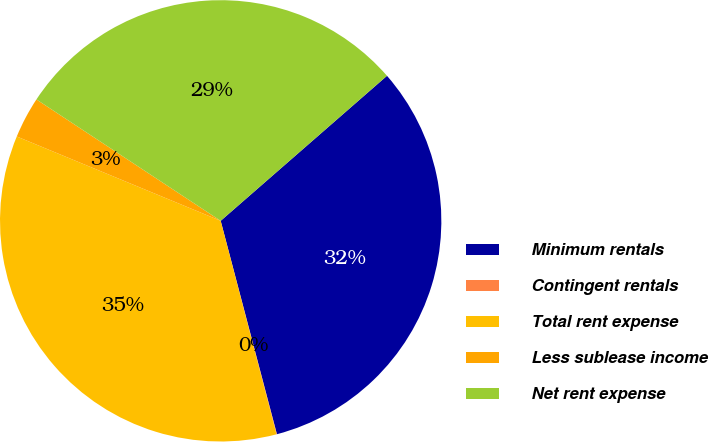Convert chart to OTSL. <chart><loc_0><loc_0><loc_500><loc_500><pie_chart><fcel>Minimum rentals<fcel>Contingent rentals<fcel>Total rent expense<fcel>Less sublease income<fcel>Net rent expense<nl><fcel>32.31%<fcel>0.03%<fcel>35.31%<fcel>3.03%<fcel>29.31%<nl></chart> 